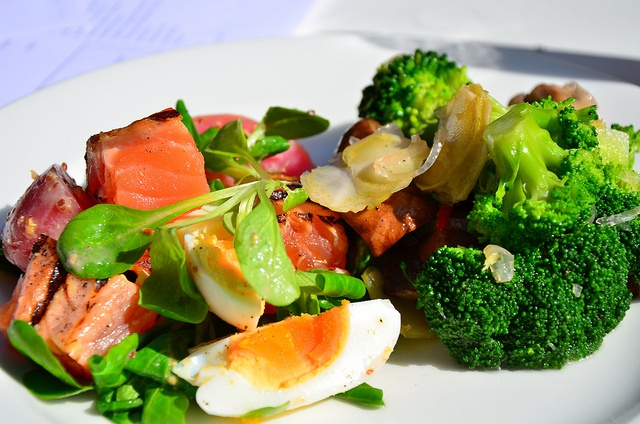Describe the objects in this image and their specific colors. I can see broccoli in lavender, black, darkgreen, green, and lime tones and broccoli in lavender, black, darkgreen, green, and lime tones in this image. 